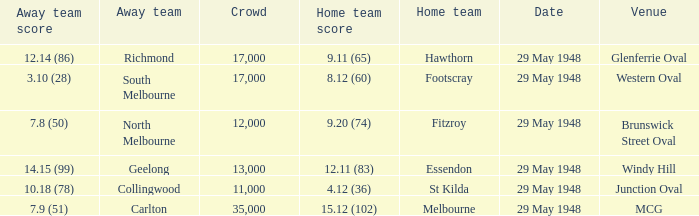In the match where footscray was the home team, how much did they score? 8.12 (60). 